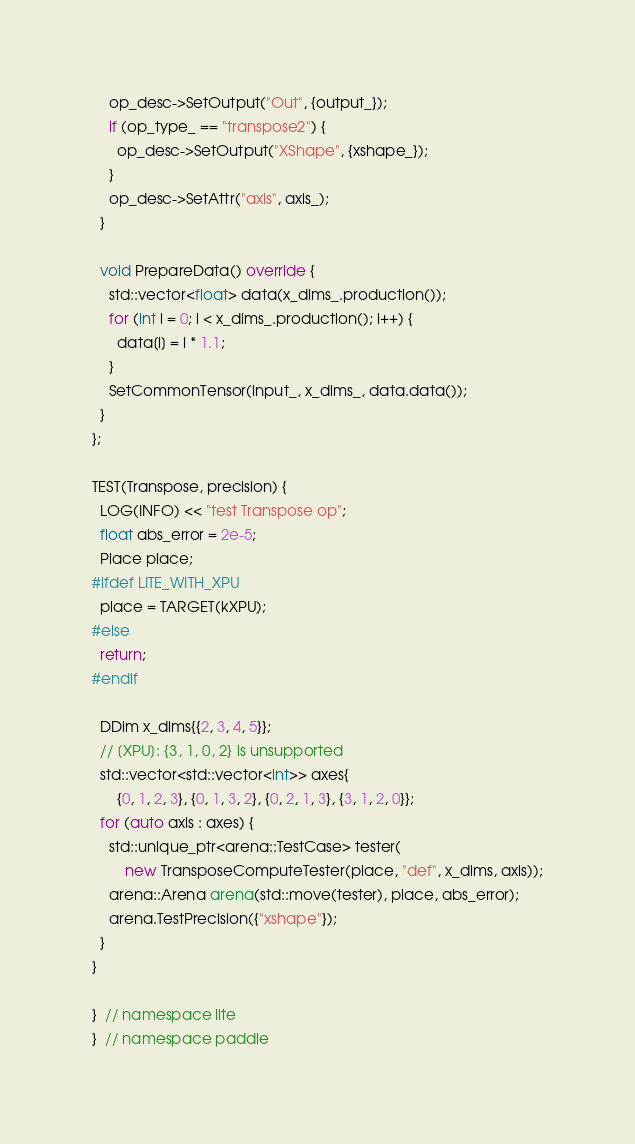<code> <loc_0><loc_0><loc_500><loc_500><_C++_>    op_desc->SetOutput("Out", {output_});
    if (op_type_ == "transpose2") {
      op_desc->SetOutput("XShape", {xshape_});
    }
    op_desc->SetAttr("axis", axis_);
  }

  void PrepareData() override {
    std::vector<float> data(x_dims_.production());
    for (int i = 0; i < x_dims_.production(); i++) {
      data[i] = i * 1.1;
    }
    SetCommonTensor(input_, x_dims_, data.data());
  }
};

TEST(Transpose, precision) {
  LOG(INFO) << "test Transpose op";
  float abs_error = 2e-5;
  Place place;
#ifdef LITE_WITH_XPU
  place = TARGET(kXPU);
#else
  return;
#endif

  DDim x_dims{{2, 3, 4, 5}};
  // [XPU]: {3, 1, 0, 2} is unsupported
  std::vector<std::vector<int>> axes{
      {0, 1, 2, 3}, {0, 1, 3, 2}, {0, 2, 1, 3}, {3, 1, 2, 0}};
  for (auto axis : axes) {
    std::unique_ptr<arena::TestCase> tester(
        new TransposeComputeTester(place, "def", x_dims, axis));
    arena::Arena arena(std::move(tester), place, abs_error);
    arena.TestPrecision({"xshape"});
  }
}

}  // namespace lite
}  // namespace paddle
</code> 